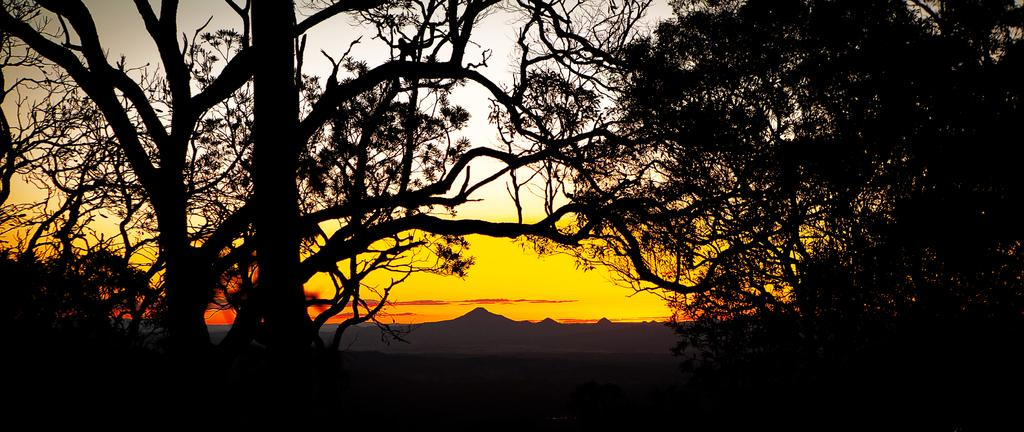What type of vegetation is in the foreground of the image? There are trees in the foreground of the image. What type of landscape feature can be seen in the background of the image? There are hills visible in the background of the image. What color is the wool used to create the art piece in the image? There is no art piece or wool present in the image; it features trees in the foreground and hills in the background. How does the balloon affect the landscape in the image? There is no balloon present in the image, so it cannot affect the landscape. 